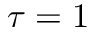Convert formula to latex. <formula><loc_0><loc_0><loc_500><loc_500>\tau = 1</formula> 